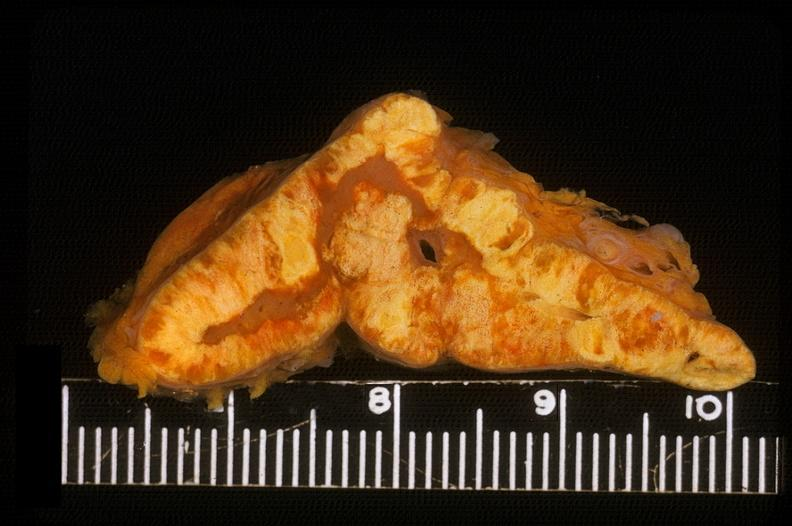where does this belong to?
Answer the question using a single word or phrase. Endocrine system 